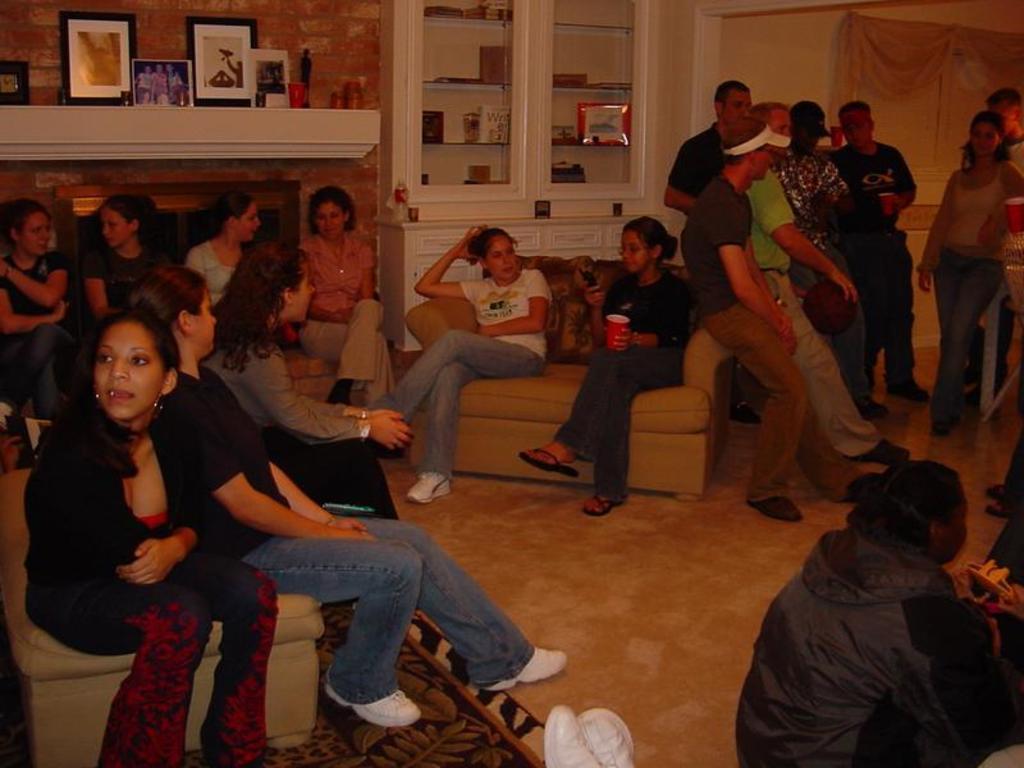Could you give a brief overview of what you see in this image? In this picture we can see some people are sitting and some people are standing. Behind the people there are photo frames, wall and some objects in the cupboards. 